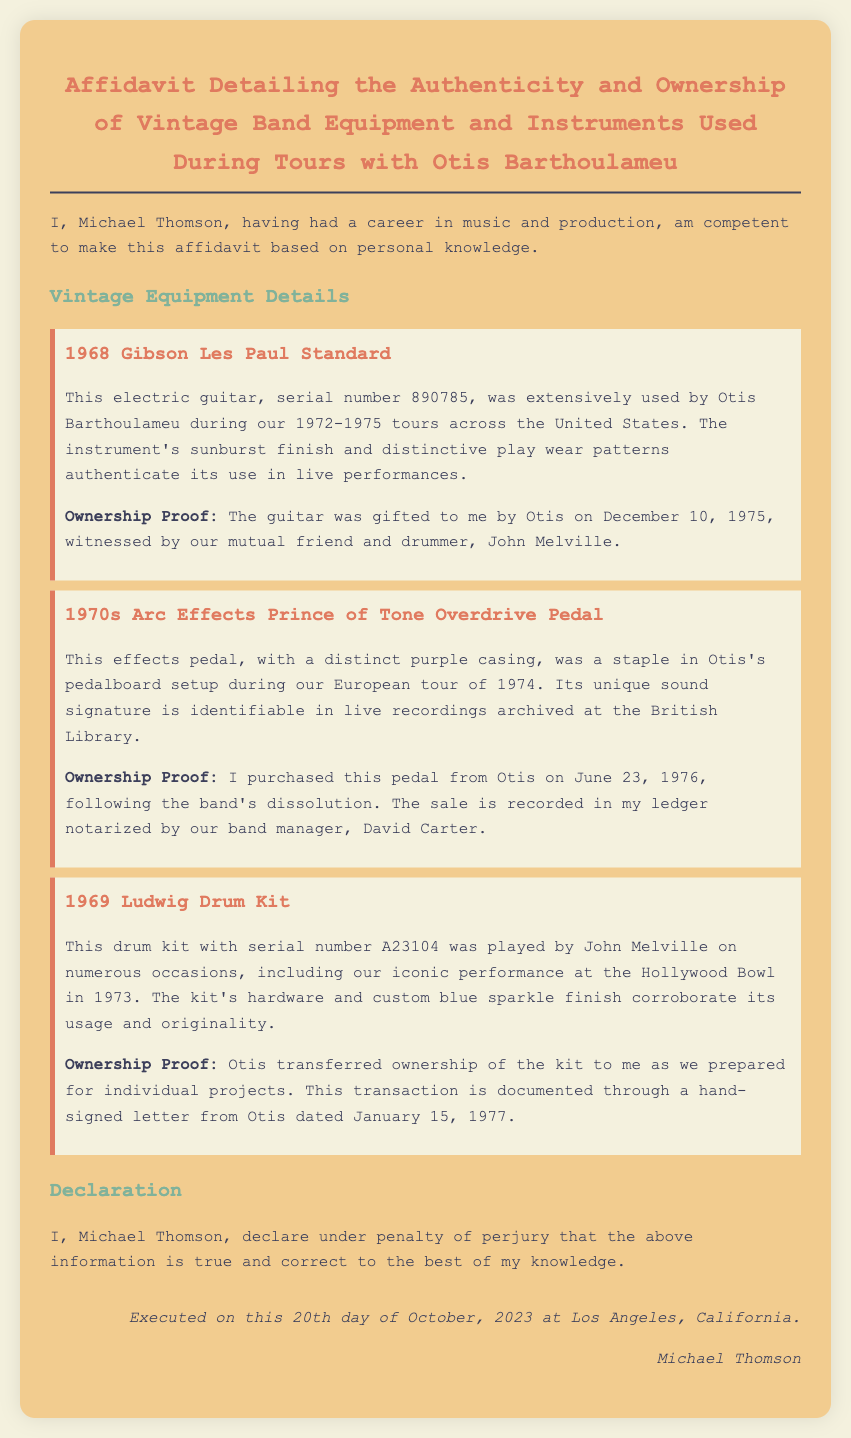What is the name of the person making the affidavit? The name of the person making the affidavit is provided at the beginning of the document as "Michael Thomson."
Answer: Michael Thomson What is the serial number of the 1969 Ludwig Drum Kit? The serial number of the drum kit is mentioned in the document as "A23104."
Answer: A23104 On what date was the 1968 Gibson Les Paul Standard gifted? The document specifies that the guitar was gifted on "December 10, 1975."
Answer: December 10, 1975 Which band member documented the sale of the 1970s Arc Effects Prince of Tone Overdrive Pedal? The sale of the pedal is documented by the band manager named "David Carter."
Answer: David Carter What is the color of the casing of the effects pedal? The document states that the color of the casing is "purple."
Answer: purple What was the iconic performance location in 1973? The document refers to the "Hollywood Bowl" as the iconic performance location in 1973.
Answer: Hollywood Bowl What does Michael Thomson declare regarding the information provided? Michael Thomson declares that the information is true and correct to the best of his knowledge, which is a statement typically found in affidavits.
Answer: true and correct When was the affidavit executed? The document mentions that the affidavit was executed on "October 20, 2023."
Answer: October 20, 2023 What type of document is this? The document clearly states in the title that it is an "Affidavit."
Answer: Affidavit 